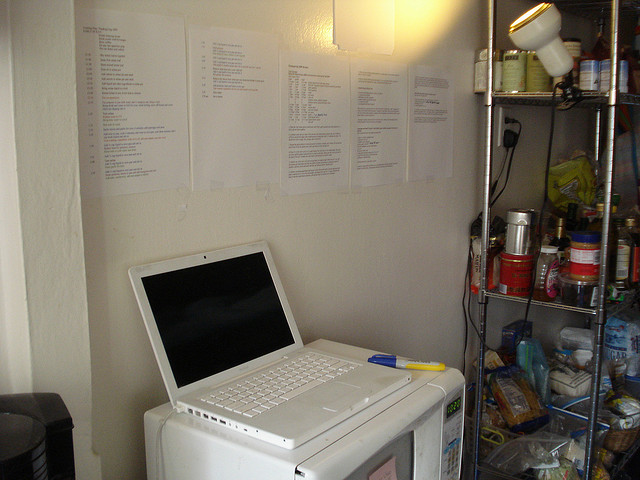What can you share about the materials stuck on the wall above the laptop? The materials pinned to the wall above the laptop appear to be printed documents or lists. Given the context, they could be recipes, study notes, reminders, or work-related information. Their placement within easy view suggests they contain important information that needs to be frequently referenced. 